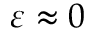Convert formula to latex. <formula><loc_0><loc_0><loc_500><loc_500>\varepsilon \approx 0</formula> 